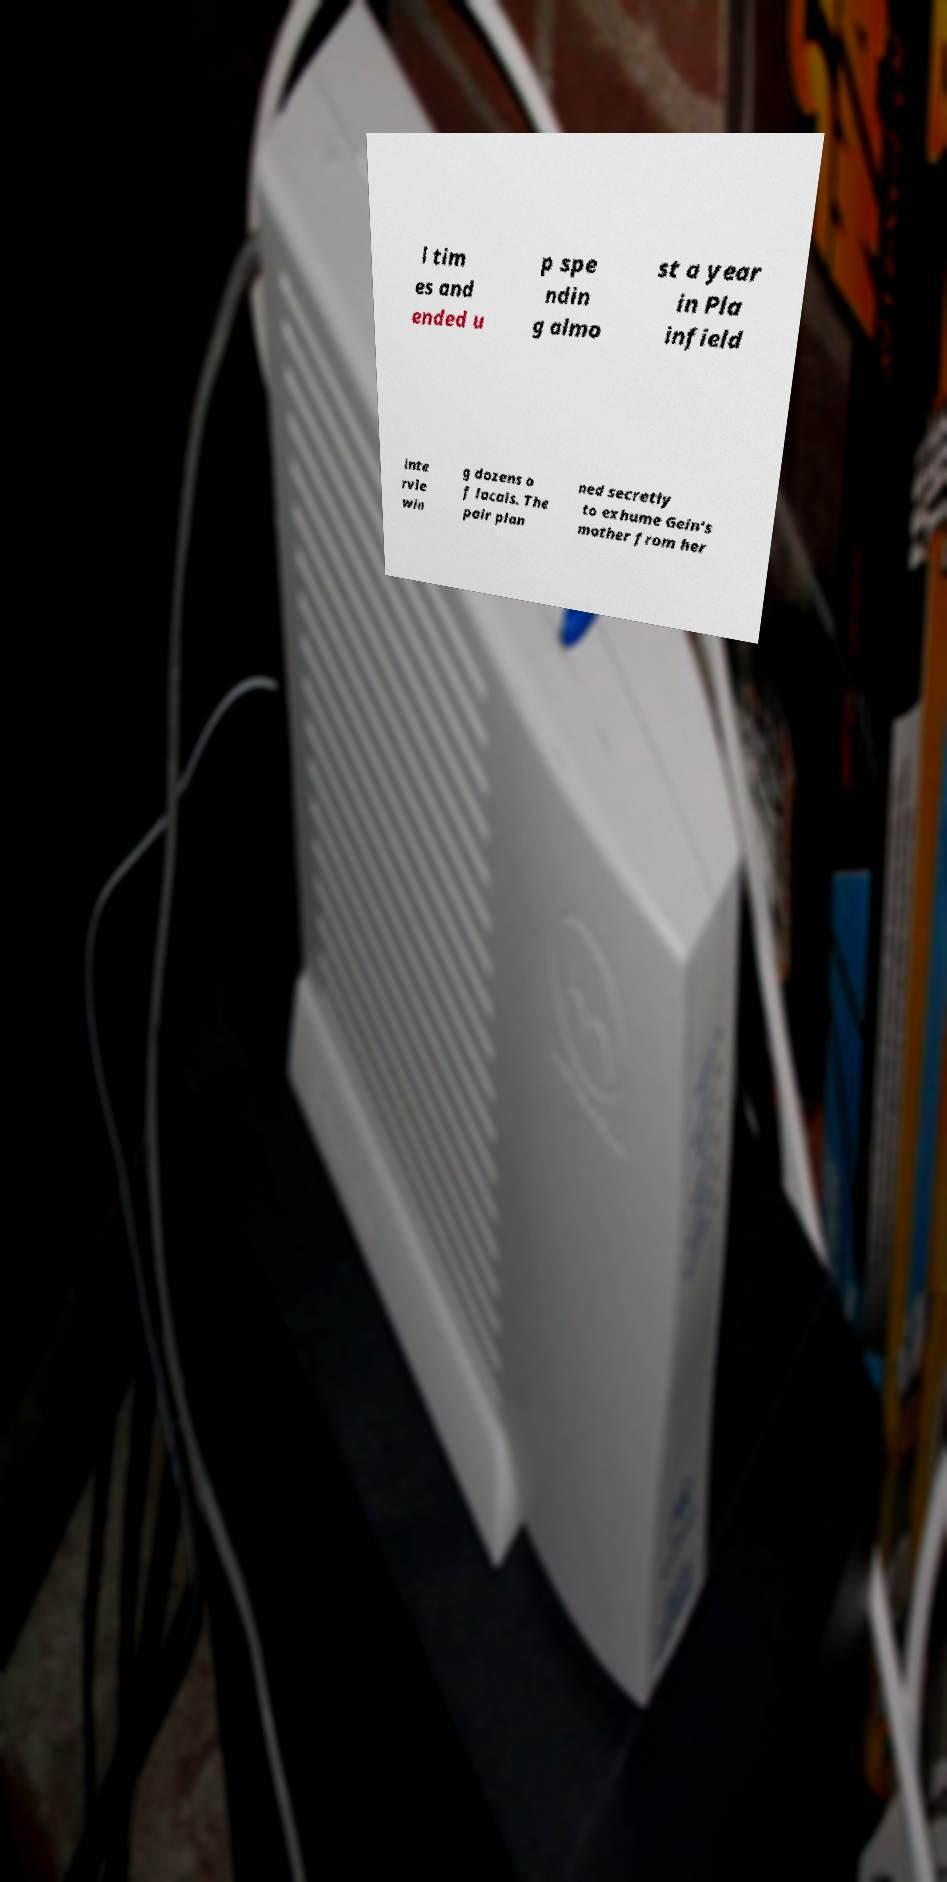There's text embedded in this image that I need extracted. Can you transcribe it verbatim? l tim es and ended u p spe ndin g almo st a year in Pla infield inte rvie win g dozens o f locals. The pair plan ned secretly to exhume Gein's mother from her 